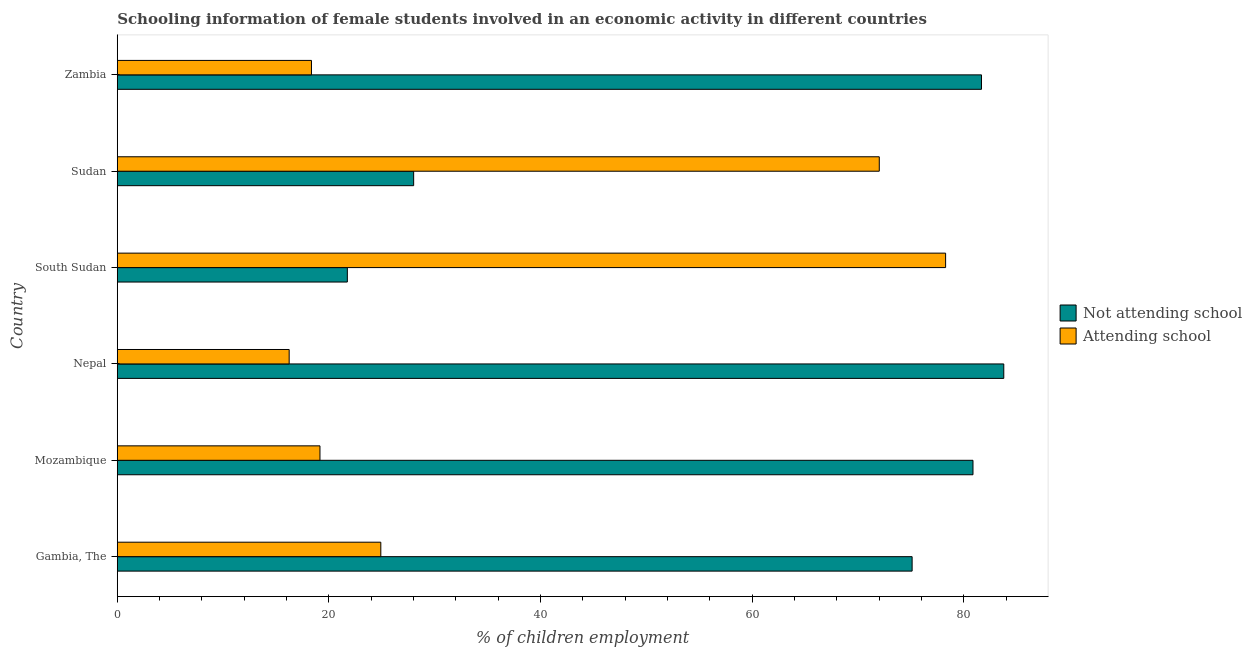How many different coloured bars are there?
Offer a terse response. 2. Are the number of bars per tick equal to the number of legend labels?
Provide a succinct answer. Yes. Are the number of bars on each tick of the Y-axis equal?
Give a very brief answer. Yes. How many bars are there on the 6th tick from the top?
Your answer should be compact. 2. How many bars are there on the 3rd tick from the bottom?
Your answer should be compact. 2. What is the label of the 1st group of bars from the top?
Your answer should be very brief. Zambia. In how many cases, is the number of bars for a given country not equal to the number of legend labels?
Provide a succinct answer. 0. What is the percentage of employed females who are attending school in Sudan?
Provide a succinct answer. 72. Across all countries, what is the maximum percentage of employed females who are not attending school?
Make the answer very short. 83.76. Across all countries, what is the minimum percentage of employed females who are attending school?
Keep it short and to the point. 16.24. In which country was the percentage of employed females who are not attending school maximum?
Provide a short and direct response. Nepal. In which country was the percentage of employed females who are attending school minimum?
Make the answer very short. Nepal. What is the total percentage of employed females who are not attending school in the graph?
Give a very brief answer. 371.1. What is the difference between the percentage of employed females who are not attending school in Nepal and that in Sudan?
Provide a succinct answer. 55.76. What is the difference between the percentage of employed females who are not attending school in Mozambique and the percentage of employed females who are attending school in Gambia, The?
Offer a terse response. 55.95. What is the average percentage of employed females who are not attending school per country?
Keep it short and to the point. 61.85. What is the difference between the percentage of employed females who are attending school and percentage of employed females who are not attending school in Sudan?
Keep it short and to the point. 43.99. In how many countries, is the percentage of employed females who are attending school greater than 56 %?
Offer a very short reply. 2. What is the ratio of the percentage of employed females who are not attending school in Gambia, The to that in Mozambique?
Your answer should be very brief. 0.93. Is the percentage of employed females who are attending school in Gambia, The less than that in Mozambique?
Your answer should be very brief. No. What is the difference between the highest and the second highest percentage of employed females who are attending school?
Your answer should be compact. 6.27. What is the difference between the highest and the lowest percentage of employed females who are not attending school?
Your response must be concise. 62.02. In how many countries, is the percentage of employed females who are attending school greater than the average percentage of employed females who are attending school taken over all countries?
Provide a succinct answer. 2. What does the 1st bar from the top in Nepal represents?
Offer a very short reply. Attending school. What does the 2nd bar from the bottom in South Sudan represents?
Offer a terse response. Attending school. How many bars are there?
Keep it short and to the point. 12. Are all the bars in the graph horizontal?
Provide a short and direct response. Yes. How many countries are there in the graph?
Provide a succinct answer. 6. Where does the legend appear in the graph?
Offer a very short reply. Center right. What is the title of the graph?
Keep it short and to the point. Schooling information of female students involved in an economic activity in different countries. What is the label or title of the X-axis?
Offer a very short reply. % of children employment. What is the % of children employment of Not attending school in Gambia, The?
Give a very brief answer. 75.1. What is the % of children employment in Attending school in Gambia, The?
Provide a short and direct response. 24.9. What is the % of children employment of Not attending school in Mozambique?
Your answer should be very brief. 80.85. What is the % of children employment of Attending school in Mozambique?
Keep it short and to the point. 19.15. What is the % of children employment of Not attending school in Nepal?
Your response must be concise. 83.76. What is the % of children employment in Attending school in Nepal?
Keep it short and to the point. 16.24. What is the % of children employment in Not attending school in South Sudan?
Your response must be concise. 21.74. What is the % of children employment of Attending school in South Sudan?
Ensure brevity in your answer.  78.26. What is the % of children employment in Not attending school in Sudan?
Your answer should be very brief. 28. What is the % of children employment of Attending school in Sudan?
Give a very brief answer. 72. What is the % of children employment in Not attending school in Zambia?
Give a very brief answer. 81.65. What is the % of children employment of Attending school in Zambia?
Give a very brief answer. 18.35. Across all countries, what is the maximum % of children employment of Not attending school?
Provide a succinct answer. 83.76. Across all countries, what is the maximum % of children employment in Attending school?
Your answer should be very brief. 78.26. Across all countries, what is the minimum % of children employment in Not attending school?
Offer a terse response. 21.74. Across all countries, what is the minimum % of children employment in Attending school?
Your answer should be compact. 16.24. What is the total % of children employment of Not attending school in the graph?
Make the answer very short. 371.1. What is the total % of children employment of Attending school in the graph?
Keep it short and to the point. 228.9. What is the difference between the % of children employment in Not attending school in Gambia, The and that in Mozambique?
Make the answer very short. -5.75. What is the difference between the % of children employment in Attending school in Gambia, The and that in Mozambique?
Ensure brevity in your answer.  5.75. What is the difference between the % of children employment in Not attending school in Gambia, The and that in Nepal?
Offer a terse response. -8.66. What is the difference between the % of children employment in Attending school in Gambia, The and that in Nepal?
Provide a short and direct response. 8.66. What is the difference between the % of children employment in Not attending school in Gambia, The and that in South Sudan?
Give a very brief answer. 53.36. What is the difference between the % of children employment of Attending school in Gambia, The and that in South Sudan?
Keep it short and to the point. -53.36. What is the difference between the % of children employment in Not attending school in Gambia, The and that in Sudan?
Make the answer very short. 47.1. What is the difference between the % of children employment of Attending school in Gambia, The and that in Sudan?
Offer a terse response. -47.1. What is the difference between the % of children employment of Not attending school in Gambia, The and that in Zambia?
Ensure brevity in your answer.  -6.55. What is the difference between the % of children employment in Attending school in Gambia, The and that in Zambia?
Ensure brevity in your answer.  6.55. What is the difference between the % of children employment of Not attending school in Mozambique and that in Nepal?
Keep it short and to the point. -2.91. What is the difference between the % of children employment in Attending school in Mozambique and that in Nepal?
Offer a very short reply. 2.91. What is the difference between the % of children employment in Not attending school in Mozambique and that in South Sudan?
Give a very brief answer. 59.11. What is the difference between the % of children employment in Attending school in Mozambique and that in South Sudan?
Your response must be concise. -59.11. What is the difference between the % of children employment of Not attending school in Mozambique and that in Sudan?
Offer a very short reply. 52.85. What is the difference between the % of children employment in Attending school in Mozambique and that in Sudan?
Make the answer very short. -52.85. What is the difference between the % of children employment in Not attending school in Mozambique and that in Zambia?
Keep it short and to the point. -0.8. What is the difference between the % of children employment in Attending school in Mozambique and that in Zambia?
Offer a terse response. 0.8. What is the difference between the % of children employment of Not attending school in Nepal and that in South Sudan?
Offer a terse response. 62.02. What is the difference between the % of children employment of Attending school in Nepal and that in South Sudan?
Ensure brevity in your answer.  -62.02. What is the difference between the % of children employment in Not attending school in Nepal and that in Sudan?
Provide a succinct answer. 55.76. What is the difference between the % of children employment in Attending school in Nepal and that in Sudan?
Provide a short and direct response. -55.76. What is the difference between the % of children employment of Not attending school in Nepal and that in Zambia?
Your answer should be compact. 2.11. What is the difference between the % of children employment of Attending school in Nepal and that in Zambia?
Offer a terse response. -2.11. What is the difference between the % of children employment in Not attending school in South Sudan and that in Sudan?
Give a very brief answer. -6.27. What is the difference between the % of children employment of Attending school in South Sudan and that in Sudan?
Give a very brief answer. 6.27. What is the difference between the % of children employment of Not attending school in South Sudan and that in Zambia?
Make the answer very short. -59.92. What is the difference between the % of children employment in Attending school in South Sudan and that in Zambia?
Ensure brevity in your answer.  59.92. What is the difference between the % of children employment of Not attending school in Sudan and that in Zambia?
Give a very brief answer. -53.65. What is the difference between the % of children employment in Attending school in Sudan and that in Zambia?
Provide a succinct answer. 53.65. What is the difference between the % of children employment in Not attending school in Gambia, The and the % of children employment in Attending school in Mozambique?
Ensure brevity in your answer.  55.95. What is the difference between the % of children employment of Not attending school in Gambia, The and the % of children employment of Attending school in Nepal?
Your answer should be compact. 58.86. What is the difference between the % of children employment in Not attending school in Gambia, The and the % of children employment in Attending school in South Sudan?
Your answer should be very brief. -3.16. What is the difference between the % of children employment in Not attending school in Gambia, The and the % of children employment in Attending school in Sudan?
Offer a very short reply. 3.1. What is the difference between the % of children employment in Not attending school in Gambia, The and the % of children employment in Attending school in Zambia?
Ensure brevity in your answer.  56.75. What is the difference between the % of children employment in Not attending school in Mozambique and the % of children employment in Attending school in Nepal?
Keep it short and to the point. 64.61. What is the difference between the % of children employment in Not attending school in Mozambique and the % of children employment in Attending school in South Sudan?
Make the answer very short. 2.59. What is the difference between the % of children employment of Not attending school in Mozambique and the % of children employment of Attending school in Sudan?
Your answer should be compact. 8.85. What is the difference between the % of children employment in Not attending school in Mozambique and the % of children employment in Attending school in Zambia?
Provide a succinct answer. 62.5. What is the difference between the % of children employment of Not attending school in Nepal and the % of children employment of Attending school in South Sudan?
Offer a terse response. 5.5. What is the difference between the % of children employment of Not attending school in Nepal and the % of children employment of Attending school in Sudan?
Give a very brief answer. 11.76. What is the difference between the % of children employment of Not attending school in Nepal and the % of children employment of Attending school in Zambia?
Your answer should be compact. 65.41. What is the difference between the % of children employment in Not attending school in South Sudan and the % of children employment in Attending school in Sudan?
Offer a very short reply. -50.26. What is the difference between the % of children employment of Not attending school in South Sudan and the % of children employment of Attending school in Zambia?
Offer a very short reply. 3.39. What is the difference between the % of children employment in Not attending school in Sudan and the % of children employment in Attending school in Zambia?
Give a very brief answer. 9.66. What is the average % of children employment of Not attending school per country?
Keep it short and to the point. 61.85. What is the average % of children employment of Attending school per country?
Offer a very short reply. 38.15. What is the difference between the % of children employment of Not attending school and % of children employment of Attending school in Gambia, The?
Keep it short and to the point. 50.2. What is the difference between the % of children employment of Not attending school and % of children employment of Attending school in Mozambique?
Provide a succinct answer. 61.7. What is the difference between the % of children employment of Not attending school and % of children employment of Attending school in Nepal?
Offer a very short reply. 67.52. What is the difference between the % of children employment in Not attending school and % of children employment in Attending school in South Sudan?
Ensure brevity in your answer.  -56.53. What is the difference between the % of children employment in Not attending school and % of children employment in Attending school in Sudan?
Ensure brevity in your answer.  -43.99. What is the difference between the % of children employment in Not attending school and % of children employment in Attending school in Zambia?
Your response must be concise. 63.31. What is the ratio of the % of children employment in Not attending school in Gambia, The to that in Mozambique?
Offer a terse response. 0.93. What is the ratio of the % of children employment in Attending school in Gambia, The to that in Mozambique?
Offer a terse response. 1.3. What is the ratio of the % of children employment of Not attending school in Gambia, The to that in Nepal?
Your answer should be compact. 0.9. What is the ratio of the % of children employment in Attending school in Gambia, The to that in Nepal?
Your answer should be compact. 1.53. What is the ratio of the % of children employment in Not attending school in Gambia, The to that in South Sudan?
Offer a terse response. 3.45. What is the ratio of the % of children employment in Attending school in Gambia, The to that in South Sudan?
Provide a succinct answer. 0.32. What is the ratio of the % of children employment in Not attending school in Gambia, The to that in Sudan?
Make the answer very short. 2.68. What is the ratio of the % of children employment in Attending school in Gambia, The to that in Sudan?
Offer a very short reply. 0.35. What is the ratio of the % of children employment of Not attending school in Gambia, The to that in Zambia?
Give a very brief answer. 0.92. What is the ratio of the % of children employment in Attending school in Gambia, The to that in Zambia?
Ensure brevity in your answer.  1.36. What is the ratio of the % of children employment in Not attending school in Mozambique to that in Nepal?
Your answer should be compact. 0.97. What is the ratio of the % of children employment in Attending school in Mozambique to that in Nepal?
Keep it short and to the point. 1.18. What is the ratio of the % of children employment in Not attending school in Mozambique to that in South Sudan?
Provide a short and direct response. 3.72. What is the ratio of the % of children employment of Attending school in Mozambique to that in South Sudan?
Offer a terse response. 0.24. What is the ratio of the % of children employment of Not attending school in Mozambique to that in Sudan?
Offer a very short reply. 2.89. What is the ratio of the % of children employment of Attending school in Mozambique to that in Sudan?
Ensure brevity in your answer.  0.27. What is the ratio of the % of children employment of Not attending school in Mozambique to that in Zambia?
Your response must be concise. 0.99. What is the ratio of the % of children employment of Attending school in Mozambique to that in Zambia?
Give a very brief answer. 1.04. What is the ratio of the % of children employment in Not attending school in Nepal to that in South Sudan?
Make the answer very short. 3.85. What is the ratio of the % of children employment of Attending school in Nepal to that in South Sudan?
Provide a short and direct response. 0.21. What is the ratio of the % of children employment in Not attending school in Nepal to that in Sudan?
Offer a terse response. 2.99. What is the ratio of the % of children employment in Attending school in Nepal to that in Sudan?
Keep it short and to the point. 0.23. What is the ratio of the % of children employment of Not attending school in Nepal to that in Zambia?
Ensure brevity in your answer.  1.03. What is the ratio of the % of children employment of Attending school in Nepal to that in Zambia?
Offer a terse response. 0.89. What is the ratio of the % of children employment of Not attending school in South Sudan to that in Sudan?
Your answer should be compact. 0.78. What is the ratio of the % of children employment of Attending school in South Sudan to that in Sudan?
Provide a short and direct response. 1.09. What is the ratio of the % of children employment in Not attending school in South Sudan to that in Zambia?
Your response must be concise. 0.27. What is the ratio of the % of children employment in Attending school in South Sudan to that in Zambia?
Offer a very short reply. 4.27. What is the ratio of the % of children employment of Not attending school in Sudan to that in Zambia?
Keep it short and to the point. 0.34. What is the ratio of the % of children employment of Attending school in Sudan to that in Zambia?
Provide a short and direct response. 3.92. What is the difference between the highest and the second highest % of children employment of Not attending school?
Make the answer very short. 2.11. What is the difference between the highest and the second highest % of children employment of Attending school?
Provide a succinct answer. 6.27. What is the difference between the highest and the lowest % of children employment of Not attending school?
Offer a terse response. 62.02. What is the difference between the highest and the lowest % of children employment of Attending school?
Offer a very short reply. 62.02. 